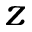<formula> <loc_0><loc_0><loc_500><loc_500>z</formula> 